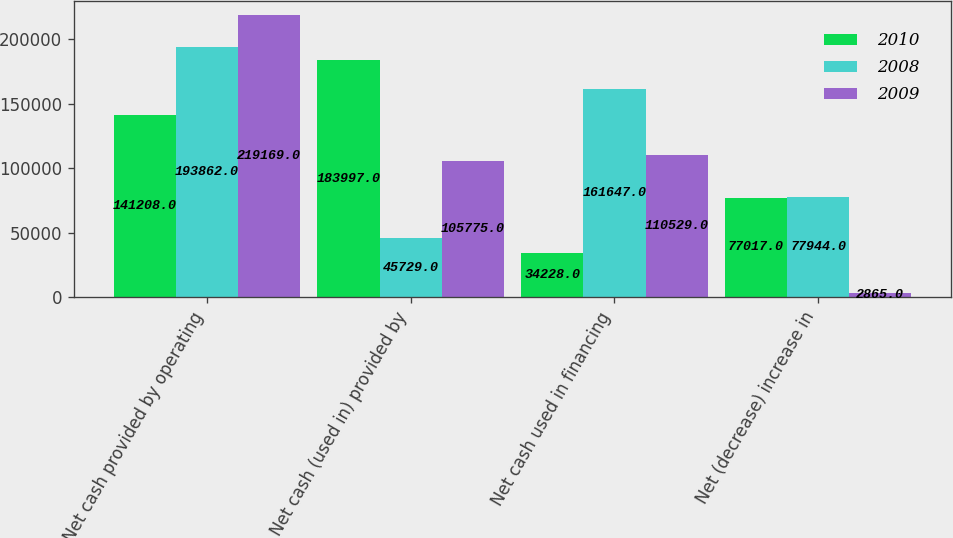<chart> <loc_0><loc_0><loc_500><loc_500><stacked_bar_chart><ecel><fcel>Net cash provided by operating<fcel>Net cash (used in) provided by<fcel>Net cash used in financing<fcel>Net (decrease) increase in<nl><fcel>2010<fcel>141208<fcel>183997<fcel>34228<fcel>77017<nl><fcel>2008<fcel>193862<fcel>45729<fcel>161647<fcel>77944<nl><fcel>2009<fcel>219169<fcel>105775<fcel>110529<fcel>2865<nl></chart> 